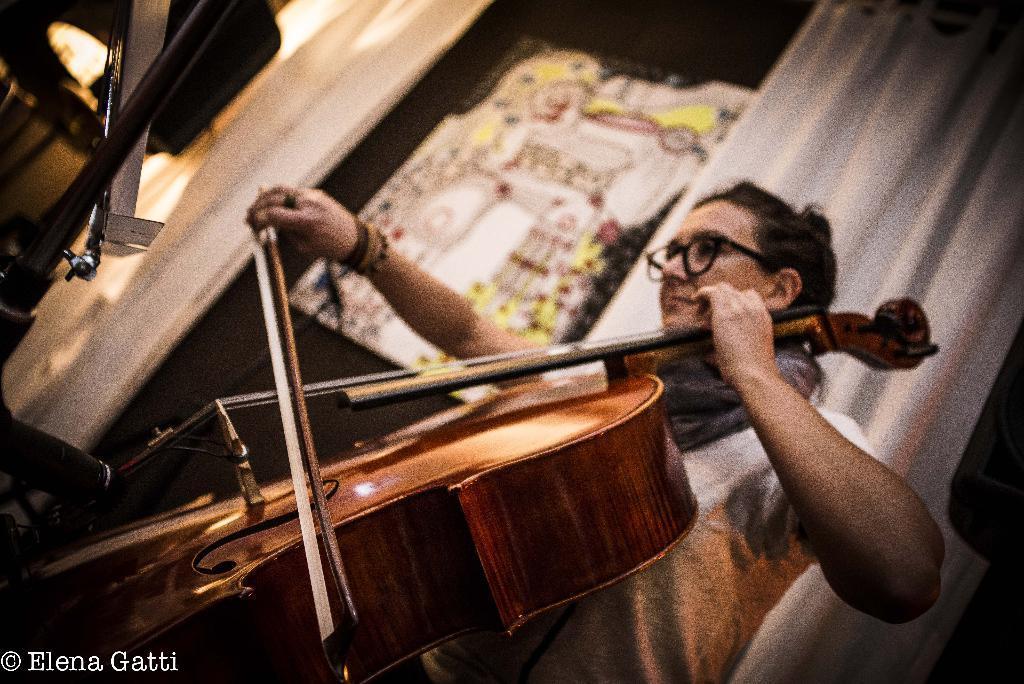How would you summarize this image in a sentence or two? In this image i can see a woman playing guitar, woman wearing white shirt at the back ground i can see a white curtain, a black door and some musical instrument. 